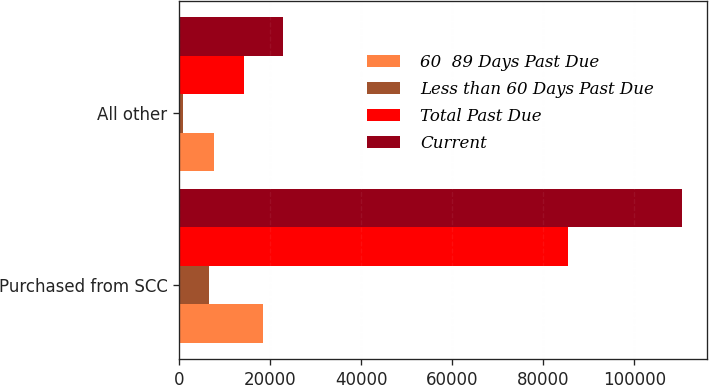Convert chart. <chart><loc_0><loc_0><loc_500><loc_500><stacked_bar_chart><ecel><fcel>Purchased from SCC<fcel>All other<nl><fcel>60  89 Days Past Due<fcel>18520<fcel>7722<nl><fcel>Less than 60 Days Past Due<fcel>6627<fcel>827<nl><fcel>Total Past Due<fcel>85303<fcel>14311<nl><fcel>Current<fcel>110450<fcel>22860<nl></chart> 